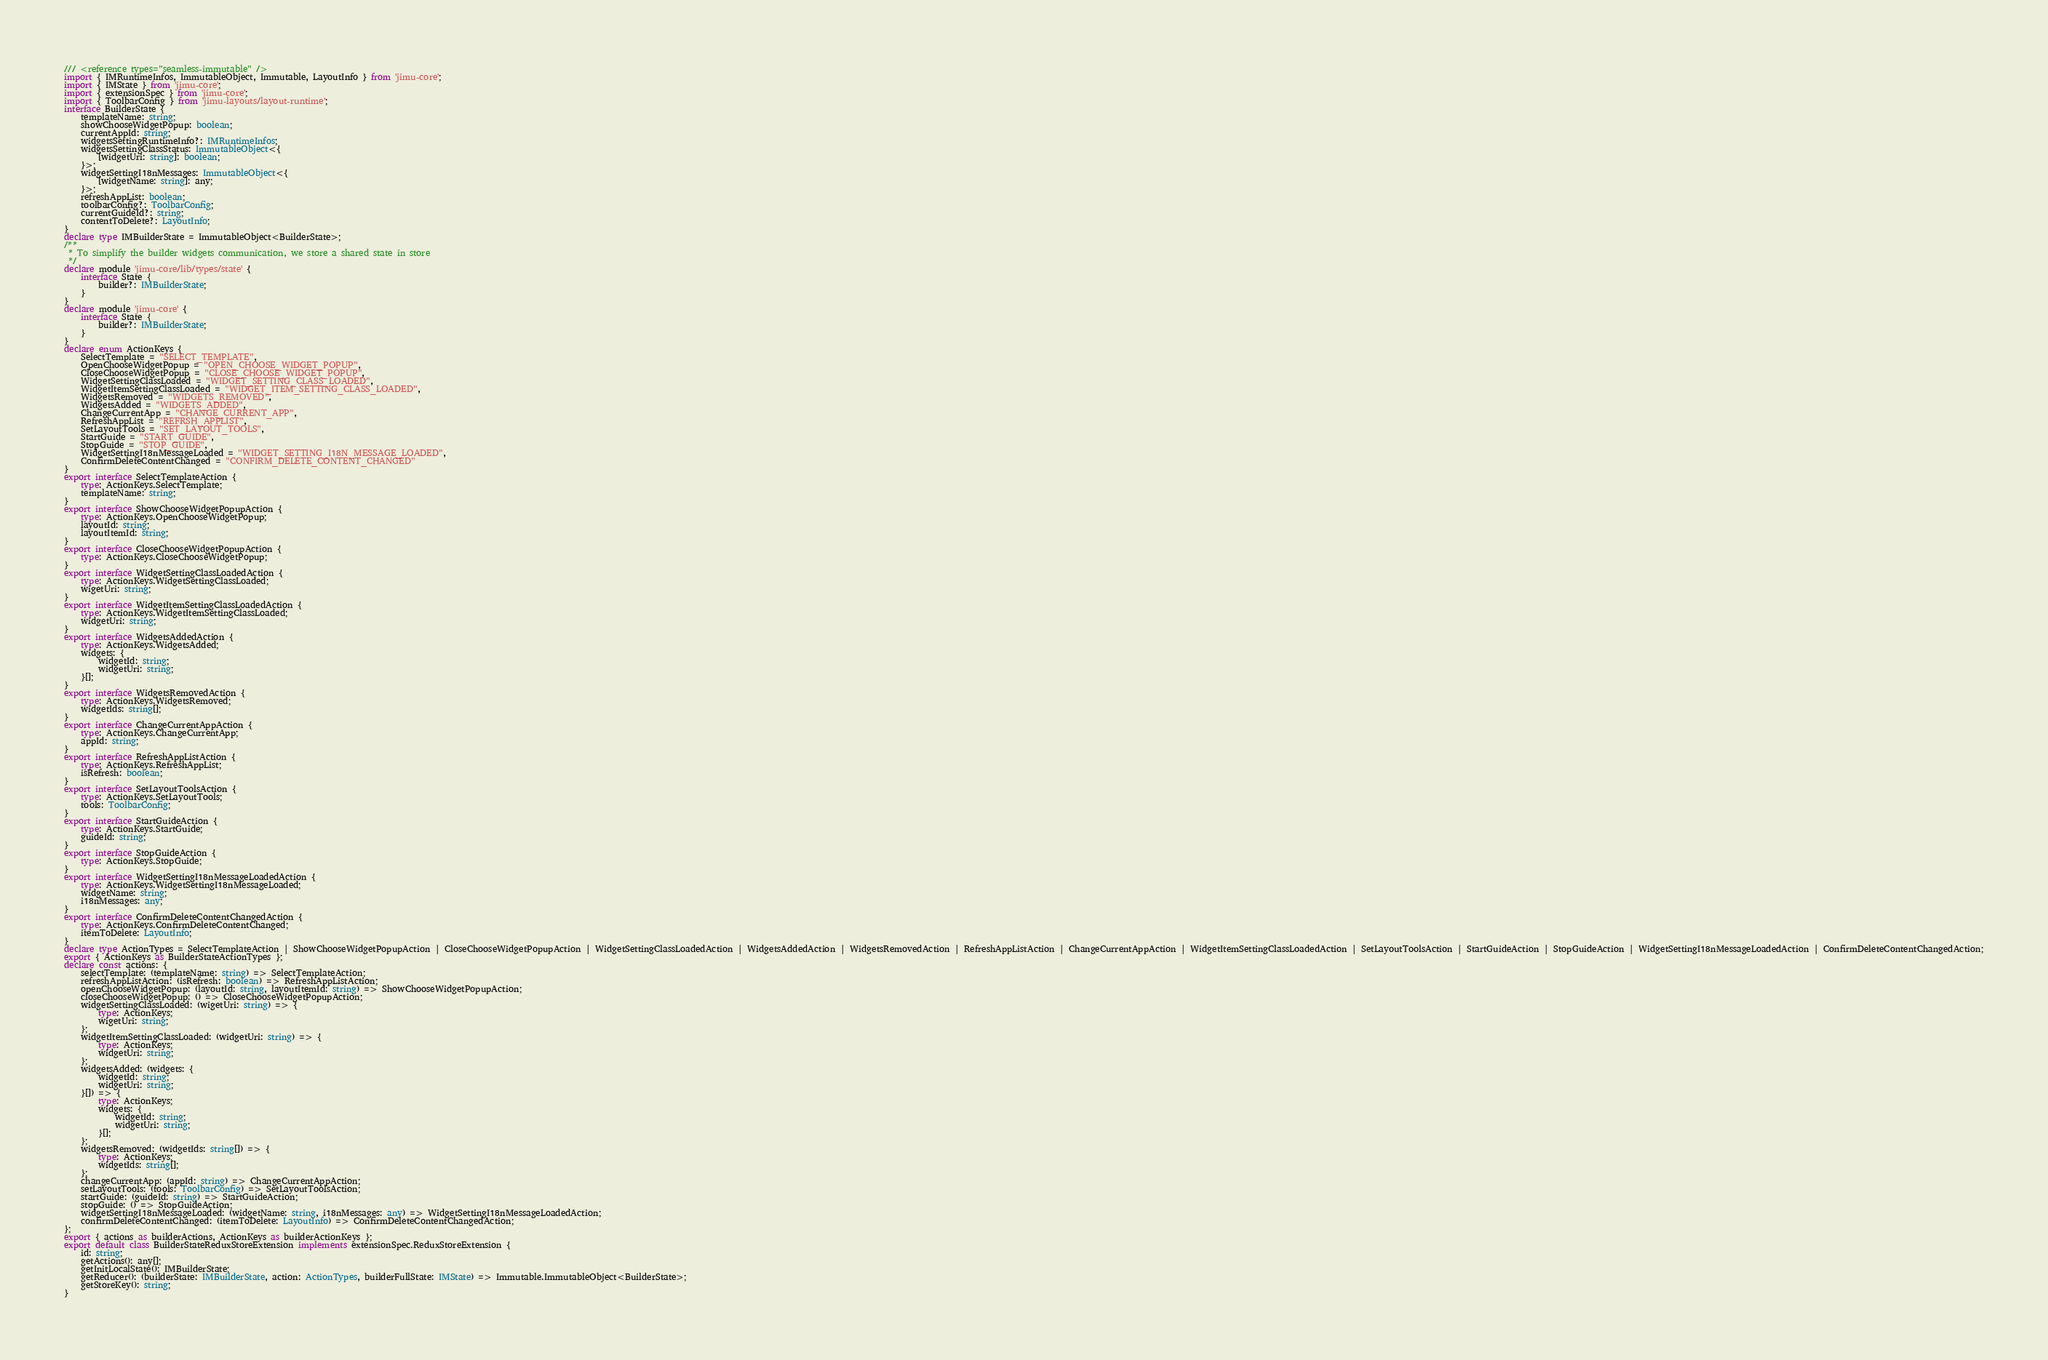Convert code to text. <code><loc_0><loc_0><loc_500><loc_500><_TypeScript_>/// <reference types="seamless-immutable" />
import { IMRuntimeInfos, ImmutableObject, Immutable, LayoutInfo } from 'jimu-core';
import { IMState } from 'jimu-core';
import { extensionSpec } from 'jimu-core';
import { ToolbarConfig } from 'jimu-layouts/layout-runtime';
interface BuilderState {
    templateName: string;
    showChooseWidgetPopup: boolean;
    currentAppId: string;
    widgetsSettingRuntimeInfo?: IMRuntimeInfos;
    widgetsSettingClassStatus: ImmutableObject<{
        [widgetUri: string]: boolean;
    }>;
    widgetSettingI18nMessages: ImmutableObject<{
        [widgetName: string]: any;
    }>;
    refreshAppList: boolean;
    toolbarConfig?: ToolbarConfig;
    currentGuideId?: string;
    contentToDelete?: LayoutInfo;
}
declare type IMBuilderState = ImmutableObject<BuilderState>;
/**
 * To simplify the builder widgets communication, we store a shared state in store
 */
declare module 'jimu-core/lib/types/state' {
    interface State {
        builder?: IMBuilderState;
    }
}
declare module 'jimu-core' {
    interface State {
        builder?: IMBuilderState;
    }
}
declare enum ActionKeys {
    SelectTemplate = "SELECT_TEMPLATE",
    OpenChooseWidgetPopup = "OPEN_CHOOSE_WIDGET_POPUP",
    CloseChooseWidgetPopup = "CLOSE_CHOOSE_WIDGET_POPUP",
    WidgetSettingClassLoaded = "WIDGET_SETTING_CLASS_LOADED",
    WidgetItemSettingClassLoaded = "WIDGET_ITEM_SETTING_CLASS_LOADED",
    WidgetsRemoved = "WIDGETS_REMOVED",
    WidgetsAdded = "WIDGETS_ADDED",
    ChangeCurrentApp = "CHANGE_CURRENT_APP",
    RefreshAppList = "REFRSH_APPLIST",
    SetLayoutTools = "SET_LAYOUT_TOOLS",
    StartGuide = "START_GUIDE",
    StopGuide = "STOP_GUIDE",
    WidgetSettingI18nMessageLoaded = "WIDGET_SETTING_I18N_MESSAGE_LOADED",
    ConfirmDeleteContentChanged = "CONFIRM_DELETE_CONTENT_CHANGED"
}
export interface SelectTemplateAction {
    type: ActionKeys.SelectTemplate;
    templateName: string;
}
export interface ShowChooseWidgetPopupAction {
    type: ActionKeys.OpenChooseWidgetPopup;
    layoutId: string;
    layoutItemId: string;
}
export interface CloseChooseWidgetPopupAction {
    type: ActionKeys.CloseChooseWidgetPopup;
}
export interface WidgetSettingClassLoadedAction {
    type: ActionKeys.WidgetSettingClassLoaded;
    wigetUri: string;
}
export interface WidgetItemSettingClassLoadedAction {
    type: ActionKeys.WidgetItemSettingClassLoaded;
    widgetUri: string;
}
export interface WidgetsAddedAction {
    type: ActionKeys.WidgetsAdded;
    widgets: {
        widgetId: string;
        widgetUri: string;
    }[];
}
export interface WidgetsRemovedAction {
    type: ActionKeys.WidgetsRemoved;
    widgetIds: string[];
}
export interface ChangeCurrentAppAction {
    type: ActionKeys.ChangeCurrentApp;
    appId: string;
}
export interface RefreshAppListAction {
    type: ActionKeys.RefreshAppList;
    isRefresh: boolean;
}
export interface SetLayoutToolsAction {
    type: ActionKeys.SetLayoutTools;
    tools: ToolbarConfig;
}
export interface StartGuideAction {
    type: ActionKeys.StartGuide;
    guideId: string;
}
export interface StopGuideAction {
    type: ActionKeys.StopGuide;
}
export interface WidgetSettingI18nMessageLoadedAction {
    type: ActionKeys.WidgetSettingI18nMessageLoaded;
    widgetName: string;
    i18nMessages: any;
}
export interface ConfirmDeleteContentChangedAction {
    type: ActionKeys.ConfirmDeleteContentChanged;
    itemToDelete: LayoutInfo;
}
declare type ActionTypes = SelectTemplateAction | ShowChooseWidgetPopupAction | CloseChooseWidgetPopupAction | WidgetSettingClassLoadedAction | WidgetsAddedAction | WidgetsRemovedAction | RefreshAppListAction | ChangeCurrentAppAction | WidgetItemSettingClassLoadedAction | SetLayoutToolsAction | StartGuideAction | StopGuideAction | WidgetSettingI18nMessageLoadedAction | ConfirmDeleteContentChangedAction;
export { ActionKeys as BuilderStateActionTypes };
declare const actions: {
    selectTemplate: (templateName: string) => SelectTemplateAction;
    refreshAppListAction: (isRefresh: boolean) => RefreshAppListAction;
    openChooseWidgetPopup: (layoutId: string, layoutItemId: string) => ShowChooseWidgetPopupAction;
    closeChooseWidgetPopup: () => CloseChooseWidgetPopupAction;
    widgetSettingClassLoaded: (wigetUri: string) => {
        type: ActionKeys;
        wigetUri: string;
    };
    widgetItemSettingClassLoaded: (widgetUri: string) => {
        type: ActionKeys;
        widgetUri: string;
    };
    widgetsAdded: (widgets: {
        widgetId: string;
        widgetUri: string;
    }[]) => {
        type: ActionKeys;
        widgets: {
            widgetId: string;
            widgetUri: string;
        }[];
    };
    widgetsRemoved: (widgetIds: string[]) => {
        type: ActionKeys;
        widgetIds: string[];
    };
    changeCurrentApp: (appId: string) => ChangeCurrentAppAction;
    setLayoutTools: (tools: ToolbarConfig) => SetLayoutToolsAction;
    startGuide: (guideId: string) => StartGuideAction;
    stopGuide: () => StopGuideAction;
    widgetSettingI18nMessageLoaded: (widgetName: string, i18nMessages: any) => WidgetSettingI18nMessageLoadedAction;
    confirmDeleteContentChanged: (itemToDelete: LayoutInfo) => ConfirmDeleteContentChangedAction;
};
export { actions as builderActions, ActionKeys as builderActionKeys };
export default class BuilderStateReduxStoreExtension implements extensionSpec.ReduxStoreExtension {
    id: string;
    getActions(): any[];
    getInitLocalState(): IMBuilderState;
    getReducer(): (builderState: IMBuilderState, action: ActionTypes, builderFullState: IMState) => Immutable.ImmutableObject<BuilderState>;
    getStoreKey(): string;
}
</code> 